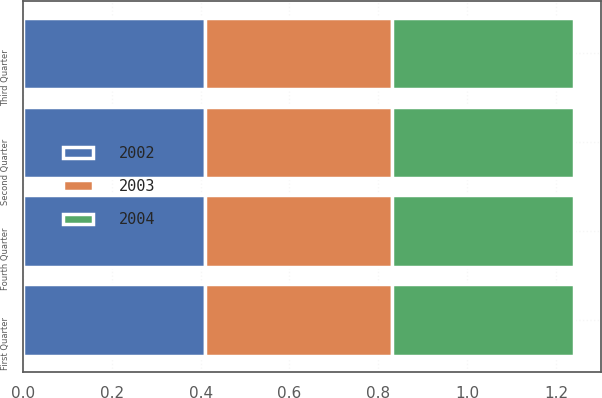<chart> <loc_0><loc_0><loc_500><loc_500><stacked_bar_chart><ecel><fcel>First Quarter<fcel>Second Quarter<fcel>Third Quarter<fcel>Fourth Quarter<nl><fcel>2003<fcel>0.42<fcel>0.42<fcel>0.42<fcel>0.42<nl><fcel>2004<fcel>0.41<fcel>0.41<fcel>0.41<fcel>0.41<nl><fcel>2002<fcel>0.41<fcel>0.41<fcel>0.41<fcel>0.41<nl></chart> 